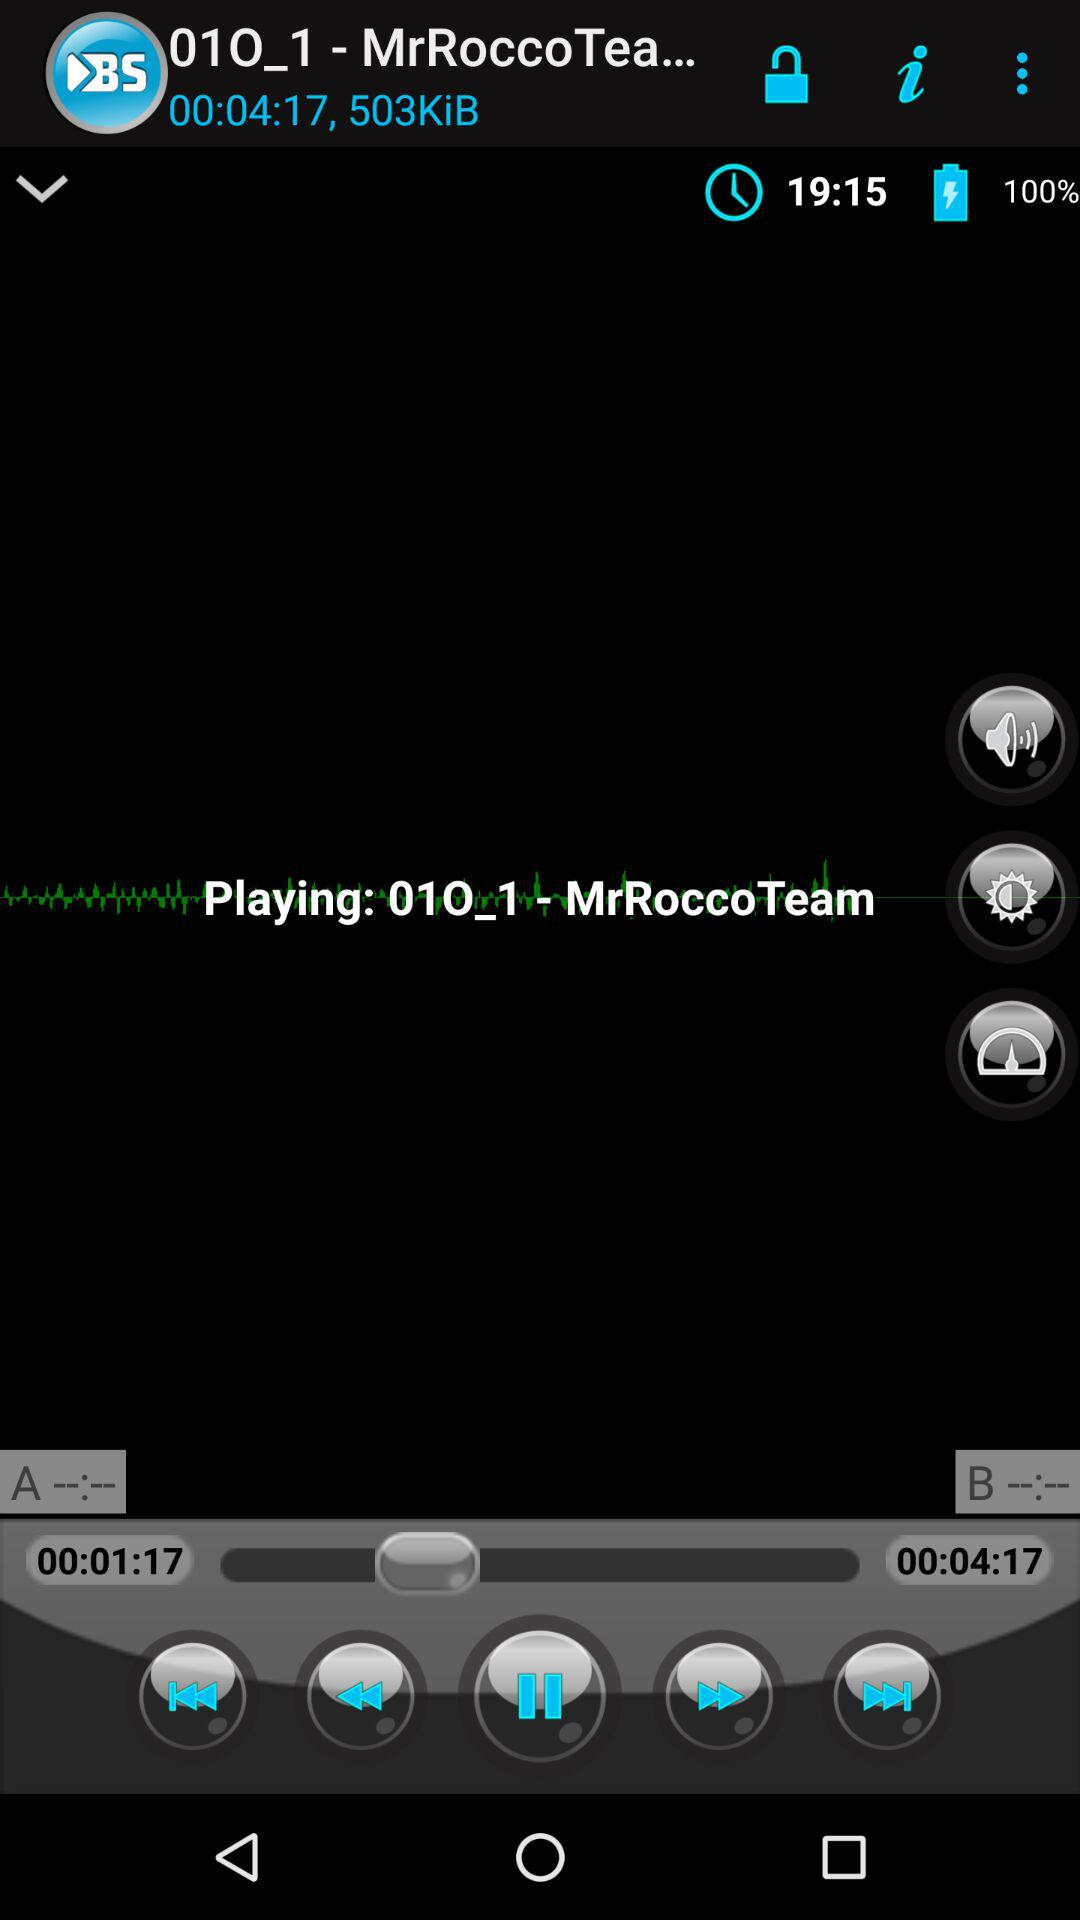What is the percentage of the battery charged?
Answer the question using a single word or phrase. 100% 